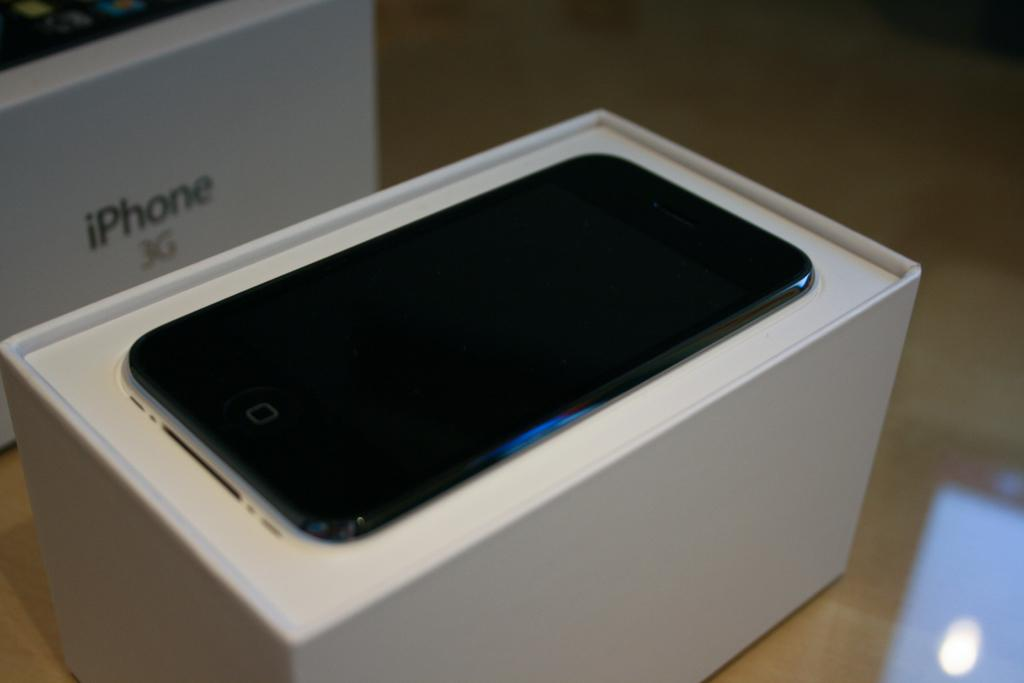<image>
Create a compact narrative representing the image presented. Black iPhone next to a white box for the iPhone 3G. 